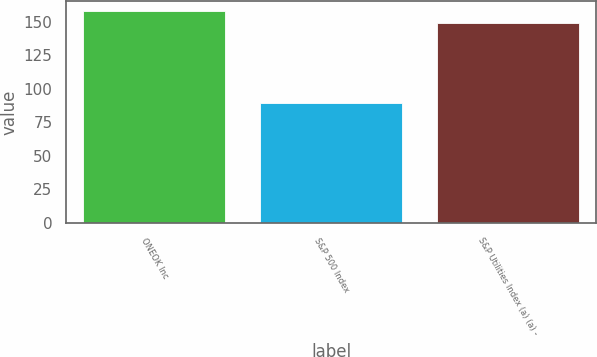<chart> <loc_0><loc_0><loc_500><loc_500><bar_chart><fcel>ONEOK Inc<fcel>S&P 500 Index<fcel>S&P Utilities Index (a) (a) -<nl><fcel>157.65<fcel>89.52<fcel>148.95<nl></chart> 